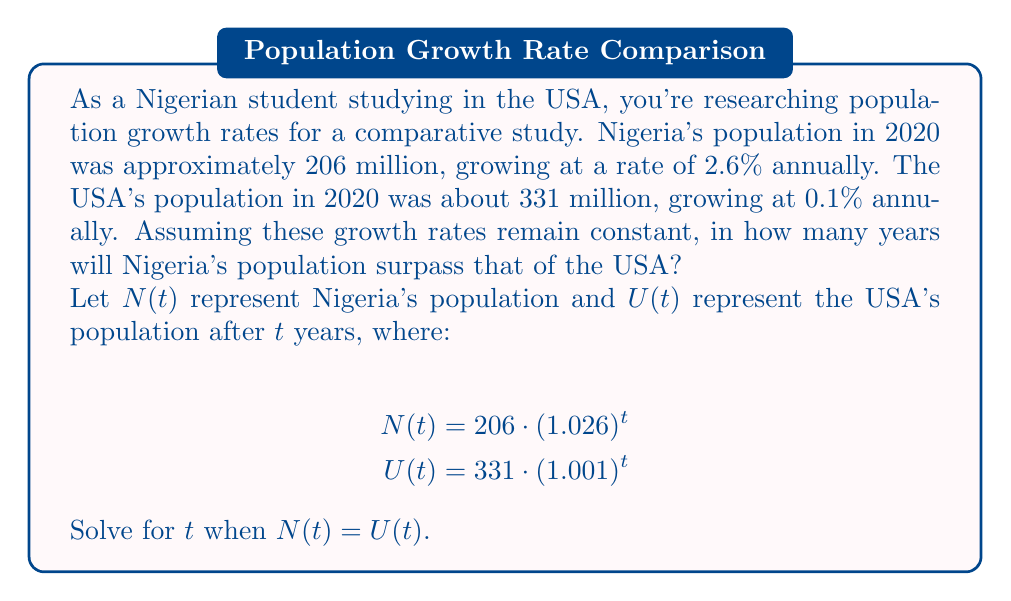Give your solution to this math problem. Let's approach this step-by-step:

1) We need to find $t$ when $N(t) = U(t)$. This gives us the equation:

   $$206 \cdot (1.026)^t = 331 \cdot (1.001)^t$$

2) Divide both sides by 206:

   $$(1.026)^t = \frac{331}{206} \cdot (1.001)^t$$

3) Take the natural logarithm of both sides:

   $$t \cdot \ln(1.026) = \ln(\frac{331}{206}) + t \cdot \ln(1.001)$$

4) Factor out $t$:

   $$t \cdot [\ln(1.026) - \ln(1.001)] = \ln(\frac{331}{206})$$

5) Solve for $t$:

   $$t = \frac{\ln(\frac{331}{206})}{\ln(1.026) - \ln(1.001)}$$

6) Now, let's calculate:
   
   $\ln(\frac{331}{206}) \approx 0.4754$
   $\ln(1.026) \approx 0.0257$
   $\ln(1.001) \approx 0.0010$

   $$t = \frac{0.4754}{0.0257 - 0.0010} \approx 19.2$$

7) Since we're dealing with years, we need to round up to the nearest whole year.
Answer: Nigeria's population will surpass that of the USA in approximately 20 years. 